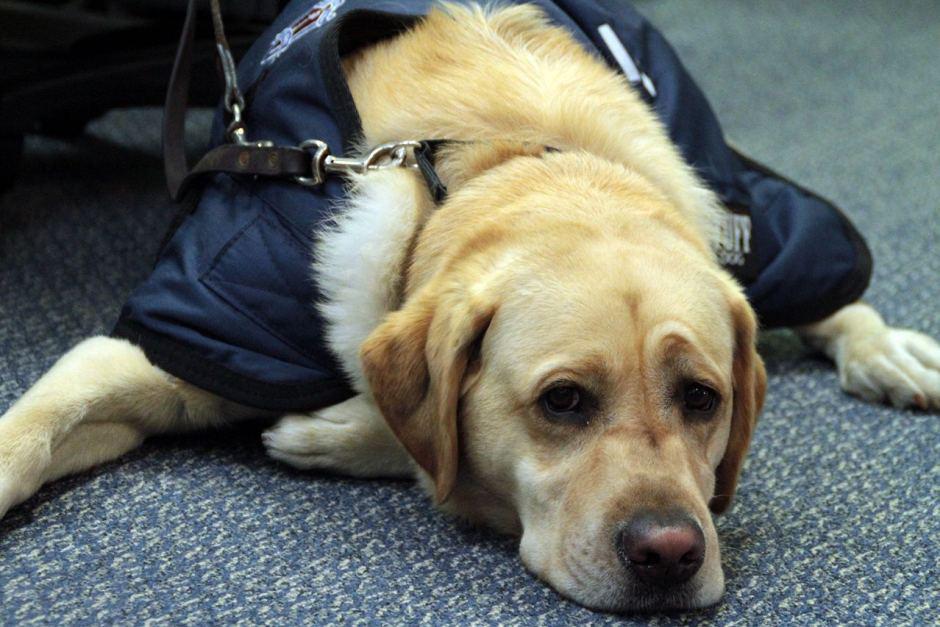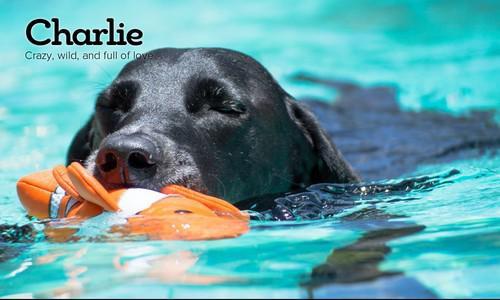The first image is the image on the left, the second image is the image on the right. Assess this claim about the two images: "There's one black lab and one chocolate lab.". Correct or not? Answer yes or no. No. The first image is the image on the left, the second image is the image on the right. Given the left and right images, does the statement "A dog appears to be lying down." hold true? Answer yes or no. Yes. 